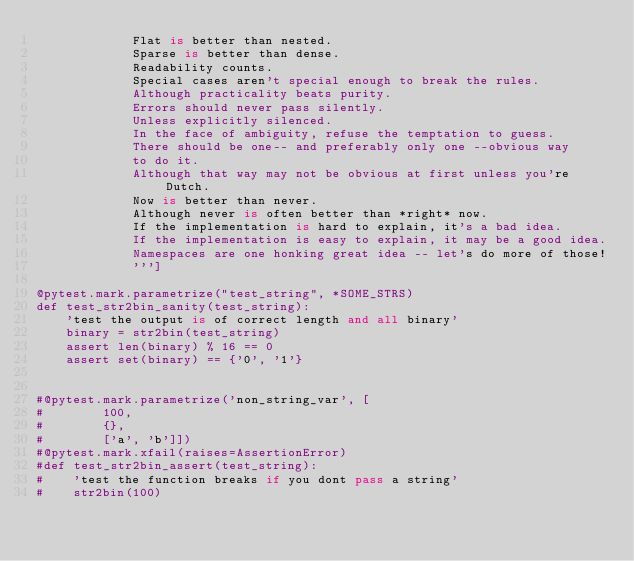Convert code to text. <code><loc_0><loc_0><loc_500><loc_500><_Python_>             Flat is better than nested.
             Sparse is better than dense.
             Readability counts.
             Special cases aren't special enough to break the rules.
             Although practicality beats purity.
             Errors should never pass silently.
             Unless explicitly silenced.
             In the face of ambiguity, refuse the temptation to guess.
             There should be one-- and preferably only one --obvious way
             to do it.
             Although that way may not be obvious at first unless you're Dutch.
             Now is better than never.
             Although never is often better than *right* now.
             If the implementation is hard to explain, it's a bad idea.
             If the implementation is easy to explain, it may be a good idea.
             Namespaces are one honking great idea -- let's do more of those!
             ''']

@pytest.mark.parametrize("test_string", *SOME_STRS)
def test_str2bin_sanity(test_string):
    'test the output is of correct length and all binary'
    binary = str2bin(test_string)
    assert len(binary) % 16 == 0
    assert set(binary) == {'0', '1'}
    

#@pytest.mark.parametrize('non_string_var', [
#        100,
#        {},
#        ['a', 'b']])
#@pytest.mark.xfail(raises=AssertionError)
#def test_str2bin_assert(test_string):
#    'test the function breaks if you dont pass a string'
#    str2bin(100)
    

    
    
    
    </code> 